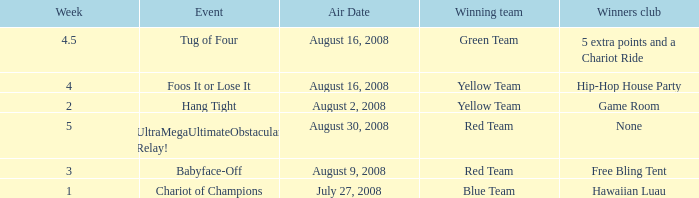Which Week has an Air Date of august 30, 2008? 5.0. 